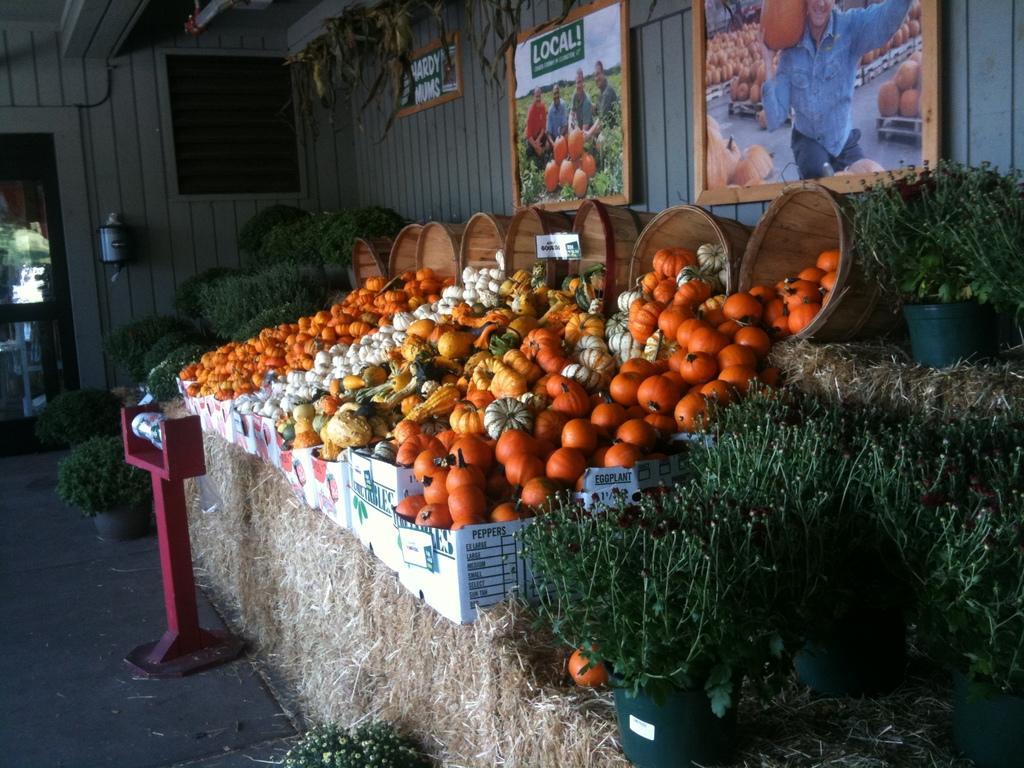In one or two sentences, can you explain what this image depicts? As we can see in the image there is wall, banners, dry grass, baskets and different types of vegetables. 